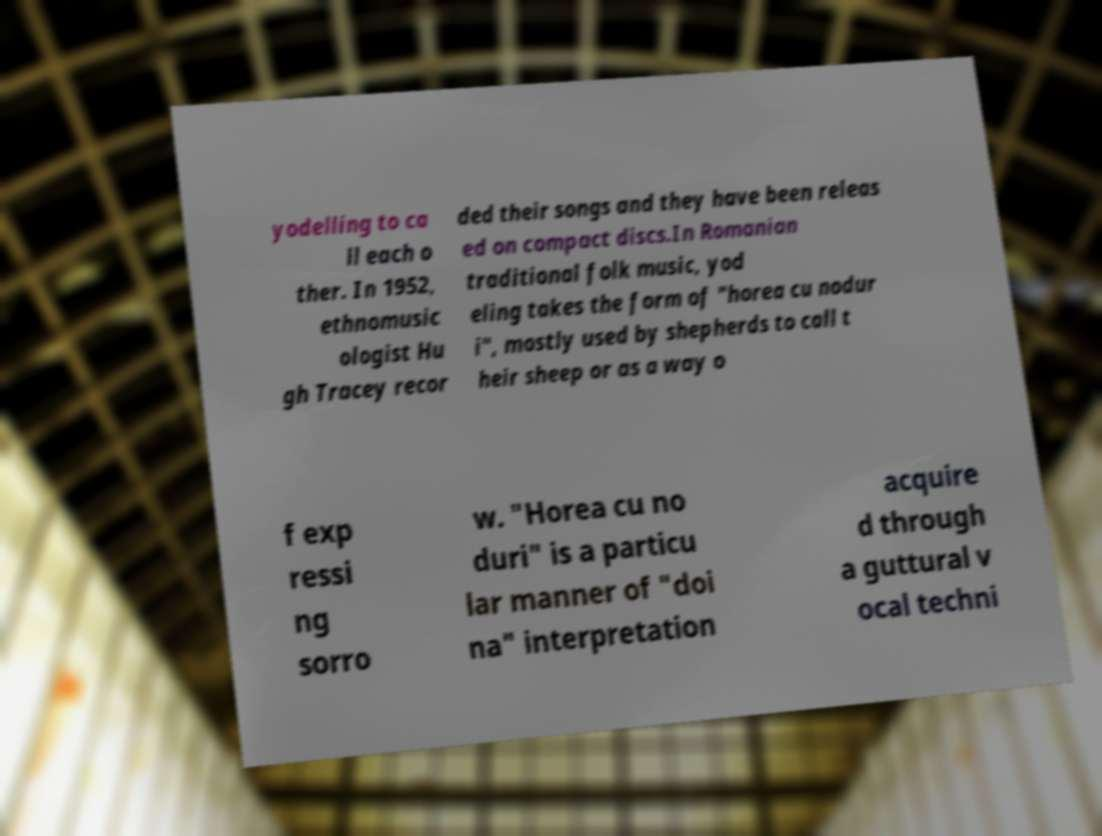I need the written content from this picture converted into text. Can you do that? yodelling to ca ll each o ther. In 1952, ethnomusic ologist Hu gh Tracey recor ded their songs and they have been releas ed on compact discs.In Romanian traditional folk music, yod eling takes the form of "horea cu nodur i", mostly used by shepherds to call t heir sheep or as a way o f exp ressi ng sorro w. "Horea cu no duri" is a particu lar manner of "doi na" interpretation acquire d through a guttural v ocal techni 